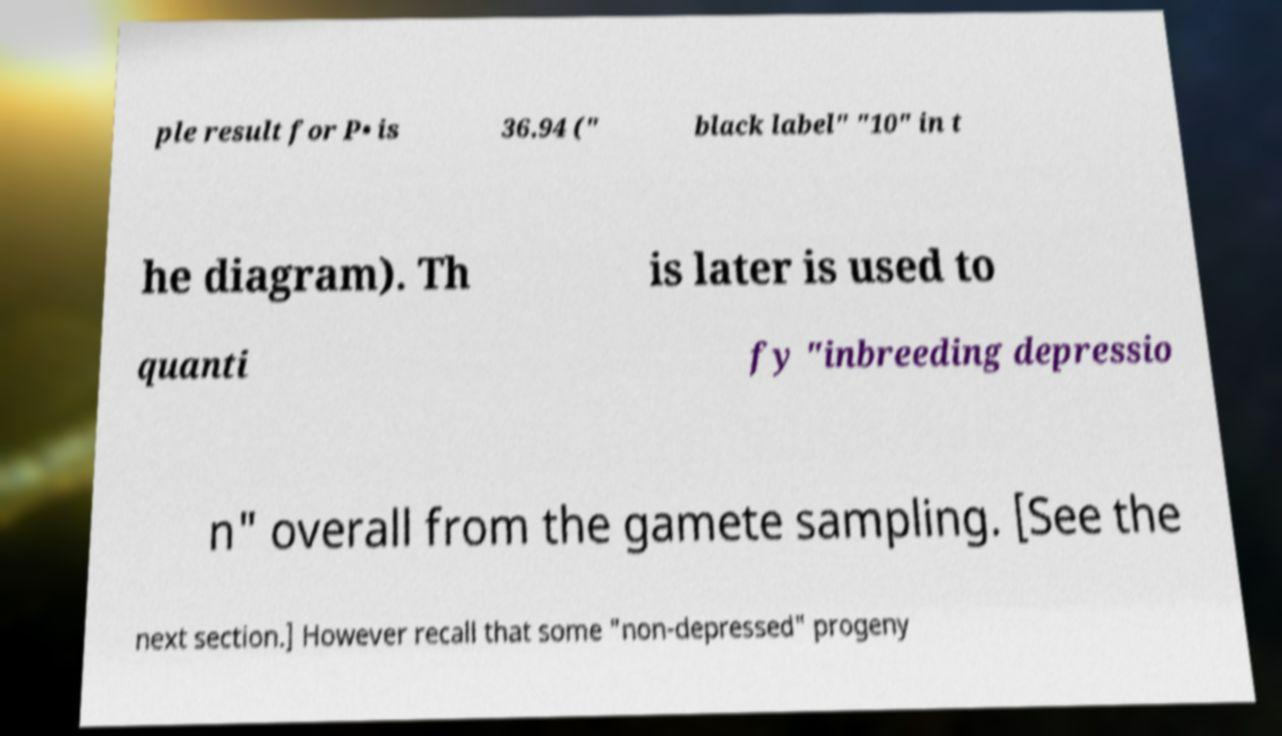I need the written content from this picture converted into text. Can you do that? ple result for P• is 36.94 (" black label" "10" in t he diagram). Th is later is used to quanti fy "inbreeding depressio n" overall from the gamete sampling. [See the next section.] However recall that some "non-depressed" progeny 